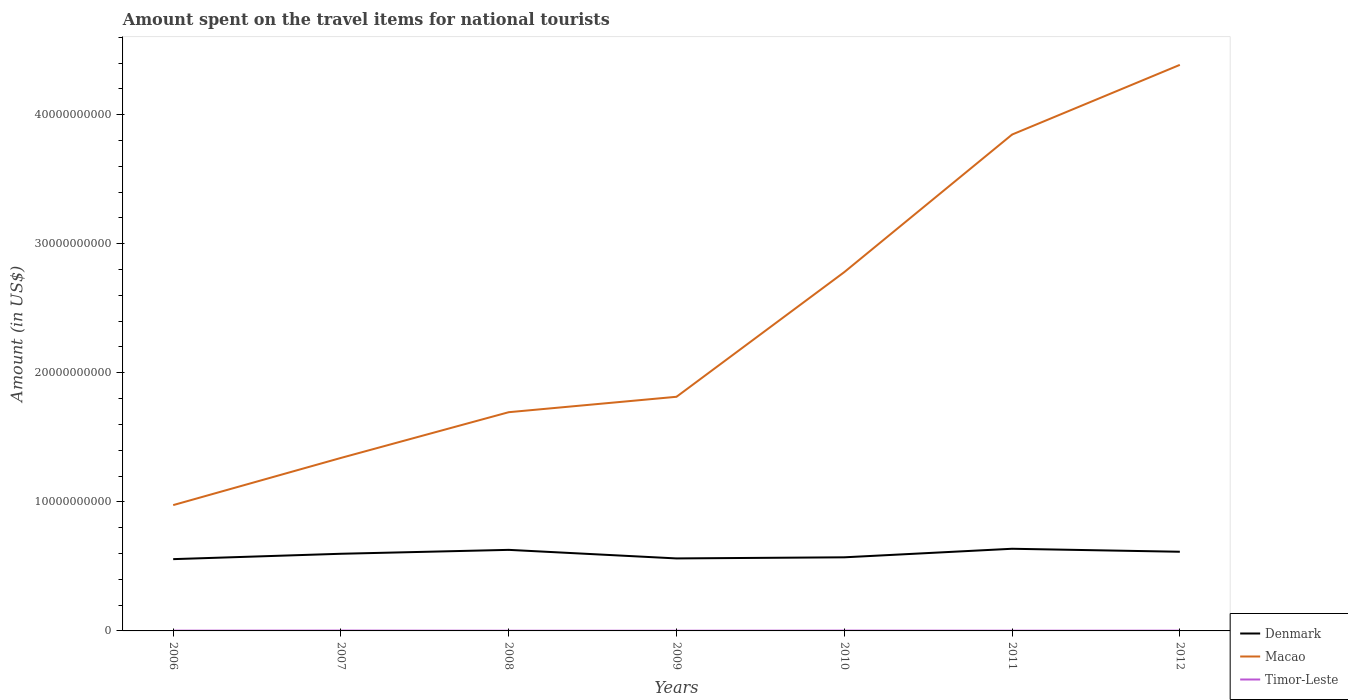How many different coloured lines are there?
Keep it short and to the point. 3. Does the line corresponding to Macao intersect with the line corresponding to Timor-Leste?
Make the answer very short. No. Is the number of lines equal to the number of legend labels?
Give a very brief answer. Yes. Across all years, what is the maximum amount spent on the travel items for national tourists in Timor-Leste?
Keep it short and to the point. 1.40e+07. In which year was the amount spent on the travel items for national tourists in Macao maximum?
Give a very brief answer. 2006. What is the total amount spent on the travel items for national tourists in Denmark in the graph?
Your response must be concise. -6.62e+08. What is the difference between the highest and the second highest amount spent on the travel items for national tourists in Denmark?
Ensure brevity in your answer.  8.04e+08. What is the difference between the highest and the lowest amount spent on the travel items for national tourists in Timor-Leste?
Ensure brevity in your answer.  4. Is the amount spent on the travel items for national tourists in Denmark strictly greater than the amount spent on the travel items for national tourists in Timor-Leste over the years?
Your answer should be compact. No. How many years are there in the graph?
Offer a terse response. 7. What is the difference between two consecutive major ticks on the Y-axis?
Keep it short and to the point. 1.00e+1. Does the graph contain any zero values?
Offer a very short reply. No. Does the graph contain grids?
Make the answer very short. No. Where does the legend appear in the graph?
Your answer should be compact. Bottom right. How many legend labels are there?
Give a very brief answer. 3. How are the legend labels stacked?
Offer a very short reply. Vertical. What is the title of the graph?
Offer a very short reply. Amount spent on the travel items for national tourists. What is the Amount (in US$) in Denmark in 2006?
Offer a very short reply. 5.56e+09. What is the Amount (in US$) in Macao in 2006?
Give a very brief answer. 9.75e+09. What is the Amount (in US$) of Timor-Leste in 2006?
Your answer should be compact. 2.00e+07. What is the Amount (in US$) in Denmark in 2007?
Make the answer very short. 5.98e+09. What is the Amount (in US$) of Macao in 2007?
Your answer should be very brief. 1.34e+1. What is the Amount (in US$) in Timor-Leste in 2007?
Make the answer very short. 2.60e+07. What is the Amount (in US$) in Denmark in 2008?
Your answer should be compact. 6.28e+09. What is the Amount (in US$) in Macao in 2008?
Offer a terse response. 1.69e+1. What is the Amount (in US$) of Timor-Leste in 2008?
Give a very brief answer. 1.40e+07. What is the Amount (in US$) of Denmark in 2009?
Your answer should be very brief. 5.62e+09. What is the Amount (in US$) of Macao in 2009?
Make the answer very short. 1.81e+1. What is the Amount (in US$) of Timor-Leste in 2009?
Make the answer very short. 1.60e+07. What is the Amount (in US$) of Denmark in 2010?
Keep it short and to the point. 5.70e+09. What is the Amount (in US$) in Macao in 2010?
Keep it short and to the point. 2.78e+1. What is the Amount (in US$) in Timor-Leste in 2010?
Offer a very short reply. 2.40e+07. What is the Amount (in US$) of Denmark in 2011?
Your response must be concise. 6.37e+09. What is the Amount (in US$) of Macao in 2011?
Ensure brevity in your answer.  3.85e+1. What is the Amount (in US$) in Timor-Leste in 2011?
Your response must be concise. 1.80e+07. What is the Amount (in US$) in Denmark in 2012?
Provide a short and direct response. 6.14e+09. What is the Amount (in US$) of Macao in 2012?
Your answer should be very brief. 4.39e+1. What is the Amount (in US$) of Timor-Leste in 2012?
Provide a succinct answer. 2.10e+07. Across all years, what is the maximum Amount (in US$) of Denmark?
Your response must be concise. 6.37e+09. Across all years, what is the maximum Amount (in US$) of Macao?
Give a very brief answer. 4.39e+1. Across all years, what is the maximum Amount (in US$) of Timor-Leste?
Your response must be concise. 2.60e+07. Across all years, what is the minimum Amount (in US$) of Denmark?
Offer a terse response. 5.56e+09. Across all years, what is the minimum Amount (in US$) of Macao?
Your answer should be very brief. 9.75e+09. Across all years, what is the minimum Amount (in US$) in Timor-Leste?
Offer a very short reply. 1.40e+07. What is the total Amount (in US$) in Denmark in the graph?
Make the answer very short. 4.16e+1. What is the total Amount (in US$) of Macao in the graph?
Make the answer very short. 1.68e+11. What is the total Amount (in US$) of Timor-Leste in the graph?
Provide a succinct answer. 1.39e+08. What is the difference between the Amount (in US$) in Denmark in 2006 and that in 2007?
Your response must be concise. -4.16e+08. What is the difference between the Amount (in US$) in Macao in 2006 and that in 2007?
Offer a terse response. -3.66e+09. What is the difference between the Amount (in US$) of Timor-Leste in 2006 and that in 2007?
Ensure brevity in your answer.  -6.00e+06. What is the difference between the Amount (in US$) of Denmark in 2006 and that in 2008?
Give a very brief answer. -7.19e+08. What is the difference between the Amount (in US$) of Macao in 2006 and that in 2008?
Your response must be concise. -7.20e+09. What is the difference between the Amount (in US$) in Timor-Leste in 2006 and that in 2008?
Provide a succinct answer. 6.00e+06. What is the difference between the Amount (in US$) in Denmark in 2006 and that in 2009?
Keep it short and to the point. -5.50e+07. What is the difference between the Amount (in US$) in Macao in 2006 and that in 2009?
Your answer should be very brief. -8.39e+09. What is the difference between the Amount (in US$) of Denmark in 2006 and that in 2010?
Your response must be concise. -1.42e+08. What is the difference between the Amount (in US$) of Macao in 2006 and that in 2010?
Make the answer very short. -1.81e+1. What is the difference between the Amount (in US$) in Timor-Leste in 2006 and that in 2010?
Give a very brief answer. -4.00e+06. What is the difference between the Amount (in US$) in Denmark in 2006 and that in 2011?
Your answer should be very brief. -8.04e+08. What is the difference between the Amount (in US$) of Macao in 2006 and that in 2011?
Your response must be concise. -2.87e+1. What is the difference between the Amount (in US$) in Timor-Leste in 2006 and that in 2011?
Keep it short and to the point. 2.00e+06. What is the difference between the Amount (in US$) in Denmark in 2006 and that in 2012?
Your response must be concise. -5.73e+08. What is the difference between the Amount (in US$) in Macao in 2006 and that in 2012?
Provide a succinct answer. -3.41e+1. What is the difference between the Amount (in US$) of Timor-Leste in 2006 and that in 2012?
Provide a short and direct response. -1.00e+06. What is the difference between the Amount (in US$) of Denmark in 2007 and that in 2008?
Make the answer very short. -3.03e+08. What is the difference between the Amount (in US$) in Macao in 2007 and that in 2008?
Keep it short and to the point. -3.54e+09. What is the difference between the Amount (in US$) in Denmark in 2007 and that in 2009?
Your answer should be very brief. 3.61e+08. What is the difference between the Amount (in US$) of Macao in 2007 and that in 2009?
Ensure brevity in your answer.  -4.74e+09. What is the difference between the Amount (in US$) of Denmark in 2007 and that in 2010?
Your answer should be very brief. 2.74e+08. What is the difference between the Amount (in US$) of Macao in 2007 and that in 2010?
Provide a succinct answer. -1.44e+1. What is the difference between the Amount (in US$) in Timor-Leste in 2007 and that in 2010?
Keep it short and to the point. 2.00e+06. What is the difference between the Amount (in US$) in Denmark in 2007 and that in 2011?
Offer a terse response. -3.88e+08. What is the difference between the Amount (in US$) of Macao in 2007 and that in 2011?
Provide a succinct answer. -2.51e+1. What is the difference between the Amount (in US$) of Denmark in 2007 and that in 2012?
Offer a terse response. -1.57e+08. What is the difference between the Amount (in US$) of Macao in 2007 and that in 2012?
Keep it short and to the point. -3.05e+1. What is the difference between the Amount (in US$) in Timor-Leste in 2007 and that in 2012?
Offer a very short reply. 5.00e+06. What is the difference between the Amount (in US$) in Denmark in 2008 and that in 2009?
Your answer should be very brief. 6.64e+08. What is the difference between the Amount (in US$) of Macao in 2008 and that in 2009?
Your response must be concise. -1.19e+09. What is the difference between the Amount (in US$) in Denmark in 2008 and that in 2010?
Provide a succinct answer. 5.77e+08. What is the difference between the Amount (in US$) of Macao in 2008 and that in 2010?
Make the answer very short. -1.09e+1. What is the difference between the Amount (in US$) in Timor-Leste in 2008 and that in 2010?
Ensure brevity in your answer.  -1.00e+07. What is the difference between the Amount (in US$) of Denmark in 2008 and that in 2011?
Keep it short and to the point. -8.50e+07. What is the difference between the Amount (in US$) of Macao in 2008 and that in 2011?
Give a very brief answer. -2.15e+1. What is the difference between the Amount (in US$) in Timor-Leste in 2008 and that in 2011?
Your answer should be very brief. -4.00e+06. What is the difference between the Amount (in US$) in Denmark in 2008 and that in 2012?
Your response must be concise. 1.46e+08. What is the difference between the Amount (in US$) in Macao in 2008 and that in 2012?
Keep it short and to the point. -2.69e+1. What is the difference between the Amount (in US$) of Timor-Leste in 2008 and that in 2012?
Provide a succinct answer. -7.00e+06. What is the difference between the Amount (in US$) in Denmark in 2009 and that in 2010?
Ensure brevity in your answer.  -8.70e+07. What is the difference between the Amount (in US$) of Macao in 2009 and that in 2010?
Offer a very short reply. -9.66e+09. What is the difference between the Amount (in US$) of Timor-Leste in 2009 and that in 2010?
Provide a short and direct response. -8.00e+06. What is the difference between the Amount (in US$) in Denmark in 2009 and that in 2011?
Keep it short and to the point. -7.49e+08. What is the difference between the Amount (in US$) in Macao in 2009 and that in 2011?
Offer a very short reply. -2.03e+1. What is the difference between the Amount (in US$) of Timor-Leste in 2009 and that in 2011?
Your response must be concise. -2.00e+06. What is the difference between the Amount (in US$) of Denmark in 2009 and that in 2012?
Keep it short and to the point. -5.18e+08. What is the difference between the Amount (in US$) in Macao in 2009 and that in 2012?
Make the answer very short. -2.57e+1. What is the difference between the Amount (in US$) of Timor-Leste in 2009 and that in 2012?
Your answer should be very brief. -5.00e+06. What is the difference between the Amount (in US$) in Denmark in 2010 and that in 2011?
Your response must be concise. -6.62e+08. What is the difference between the Amount (in US$) in Macao in 2010 and that in 2011?
Offer a terse response. -1.07e+1. What is the difference between the Amount (in US$) of Timor-Leste in 2010 and that in 2011?
Provide a short and direct response. 6.00e+06. What is the difference between the Amount (in US$) in Denmark in 2010 and that in 2012?
Offer a very short reply. -4.31e+08. What is the difference between the Amount (in US$) of Macao in 2010 and that in 2012?
Provide a succinct answer. -1.61e+1. What is the difference between the Amount (in US$) in Denmark in 2011 and that in 2012?
Offer a terse response. 2.31e+08. What is the difference between the Amount (in US$) of Macao in 2011 and that in 2012?
Provide a succinct answer. -5.40e+09. What is the difference between the Amount (in US$) of Timor-Leste in 2011 and that in 2012?
Your answer should be compact. -3.00e+06. What is the difference between the Amount (in US$) of Denmark in 2006 and the Amount (in US$) of Macao in 2007?
Provide a succinct answer. -7.84e+09. What is the difference between the Amount (in US$) of Denmark in 2006 and the Amount (in US$) of Timor-Leste in 2007?
Provide a succinct answer. 5.54e+09. What is the difference between the Amount (in US$) of Macao in 2006 and the Amount (in US$) of Timor-Leste in 2007?
Your response must be concise. 9.72e+09. What is the difference between the Amount (in US$) in Denmark in 2006 and the Amount (in US$) in Macao in 2008?
Make the answer very short. -1.14e+1. What is the difference between the Amount (in US$) in Denmark in 2006 and the Amount (in US$) in Timor-Leste in 2008?
Your answer should be compact. 5.55e+09. What is the difference between the Amount (in US$) of Macao in 2006 and the Amount (in US$) of Timor-Leste in 2008?
Your answer should be very brief. 9.74e+09. What is the difference between the Amount (in US$) in Denmark in 2006 and the Amount (in US$) in Macao in 2009?
Your response must be concise. -1.26e+1. What is the difference between the Amount (in US$) in Denmark in 2006 and the Amount (in US$) in Timor-Leste in 2009?
Keep it short and to the point. 5.55e+09. What is the difference between the Amount (in US$) in Macao in 2006 and the Amount (in US$) in Timor-Leste in 2009?
Offer a terse response. 9.73e+09. What is the difference between the Amount (in US$) of Denmark in 2006 and the Amount (in US$) of Macao in 2010?
Keep it short and to the point. -2.22e+1. What is the difference between the Amount (in US$) of Denmark in 2006 and the Amount (in US$) of Timor-Leste in 2010?
Make the answer very short. 5.54e+09. What is the difference between the Amount (in US$) of Macao in 2006 and the Amount (in US$) of Timor-Leste in 2010?
Make the answer very short. 9.72e+09. What is the difference between the Amount (in US$) in Denmark in 2006 and the Amount (in US$) in Macao in 2011?
Your answer should be very brief. -3.29e+1. What is the difference between the Amount (in US$) of Denmark in 2006 and the Amount (in US$) of Timor-Leste in 2011?
Give a very brief answer. 5.54e+09. What is the difference between the Amount (in US$) of Macao in 2006 and the Amount (in US$) of Timor-Leste in 2011?
Your answer should be very brief. 9.73e+09. What is the difference between the Amount (in US$) in Denmark in 2006 and the Amount (in US$) in Macao in 2012?
Provide a succinct answer. -3.83e+1. What is the difference between the Amount (in US$) of Denmark in 2006 and the Amount (in US$) of Timor-Leste in 2012?
Provide a succinct answer. 5.54e+09. What is the difference between the Amount (in US$) in Macao in 2006 and the Amount (in US$) in Timor-Leste in 2012?
Ensure brevity in your answer.  9.73e+09. What is the difference between the Amount (in US$) of Denmark in 2007 and the Amount (in US$) of Macao in 2008?
Your answer should be compact. -1.10e+1. What is the difference between the Amount (in US$) in Denmark in 2007 and the Amount (in US$) in Timor-Leste in 2008?
Your answer should be very brief. 5.96e+09. What is the difference between the Amount (in US$) of Macao in 2007 and the Amount (in US$) of Timor-Leste in 2008?
Your answer should be very brief. 1.34e+1. What is the difference between the Amount (in US$) in Denmark in 2007 and the Amount (in US$) in Macao in 2009?
Provide a succinct answer. -1.22e+1. What is the difference between the Amount (in US$) in Denmark in 2007 and the Amount (in US$) in Timor-Leste in 2009?
Offer a very short reply. 5.96e+09. What is the difference between the Amount (in US$) in Macao in 2007 and the Amount (in US$) in Timor-Leste in 2009?
Give a very brief answer. 1.34e+1. What is the difference between the Amount (in US$) of Denmark in 2007 and the Amount (in US$) of Macao in 2010?
Make the answer very short. -2.18e+1. What is the difference between the Amount (in US$) of Denmark in 2007 and the Amount (in US$) of Timor-Leste in 2010?
Your answer should be very brief. 5.95e+09. What is the difference between the Amount (in US$) of Macao in 2007 and the Amount (in US$) of Timor-Leste in 2010?
Your response must be concise. 1.34e+1. What is the difference between the Amount (in US$) of Denmark in 2007 and the Amount (in US$) of Macao in 2011?
Offer a very short reply. -3.25e+1. What is the difference between the Amount (in US$) in Denmark in 2007 and the Amount (in US$) in Timor-Leste in 2011?
Make the answer very short. 5.96e+09. What is the difference between the Amount (in US$) of Macao in 2007 and the Amount (in US$) of Timor-Leste in 2011?
Ensure brevity in your answer.  1.34e+1. What is the difference between the Amount (in US$) of Denmark in 2007 and the Amount (in US$) of Macao in 2012?
Ensure brevity in your answer.  -3.79e+1. What is the difference between the Amount (in US$) of Denmark in 2007 and the Amount (in US$) of Timor-Leste in 2012?
Provide a succinct answer. 5.96e+09. What is the difference between the Amount (in US$) in Macao in 2007 and the Amount (in US$) in Timor-Leste in 2012?
Your response must be concise. 1.34e+1. What is the difference between the Amount (in US$) in Denmark in 2008 and the Amount (in US$) in Macao in 2009?
Offer a very short reply. -1.19e+1. What is the difference between the Amount (in US$) in Denmark in 2008 and the Amount (in US$) in Timor-Leste in 2009?
Make the answer very short. 6.26e+09. What is the difference between the Amount (in US$) in Macao in 2008 and the Amount (in US$) in Timor-Leste in 2009?
Offer a very short reply. 1.69e+1. What is the difference between the Amount (in US$) in Denmark in 2008 and the Amount (in US$) in Macao in 2010?
Offer a very short reply. -2.15e+1. What is the difference between the Amount (in US$) in Denmark in 2008 and the Amount (in US$) in Timor-Leste in 2010?
Ensure brevity in your answer.  6.26e+09. What is the difference between the Amount (in US$) in Macao in 2008 and the Amount (in US$) in Timor-Leste in 2010?
Give a very brief answer. 1.69e+1. What is the difference between the Amount (in US$) in Denmark in 2008 and the Amount (in US$) in Macao in 2011?
Provide a succinct answer. -3.22e+1. What is the difference between the Amount (in US$) in Denmark in 2008 and the Amount (in US$) in Timor-Leste in 2011?
Offer a very short reply. 6.26e+09. What is the difference between the Amount (in US$) of Macao in 2008 and the Amount (in US$) of Timor-Leste in 2011?
Your answer should be very brief. 1.69e+1. What is the difference between the Amount (in US$) in Denmark in 2008 and the Amount (in US$) in Macao in 2012?
Make the answer very short. -3.76e+1. What is the difference between the Amount (in US$) in Denmark in 2008 and the Amount (in US$) in Timor-Leste in 2012?
Offer a terse response. 6.26e+09. What is the difference between the Amount (in US$) in Macao in 2008 and the Amount (in US$) in Timor-Leste in 2012?
Keep it short and to the point. 1.69e+1. What is the difference between the Amount (in US$) in Denmark in 2009 and the Amount (in US$) in Macao in 2010?
Your response must be concise. -2.22e+1. What is the difference between the Amount (in US$) of Denmark in 2009 and the Amount (in US$) of Timor-Leste in 2010?
Your answer should be compact. 5.59e+09. What is the difference between the Amount (in US$) in Macao in 2009 and the Amount (in US$) in Timor-Leste in 2010?
Give a very brief answer. 1.81e+1. What is the difference between the Amount (in US$) in Denmark in 2009 and the Amount (in US$) in Macao in 2011?
Make the answer very short. -3.28e+1. What is the difference between the Amount (in US$) in Denmark in 2009 and the Amount (in US$) in Timor-Leste in 2011?
Provide a short and direct response. 5.60e+09. What is the difference between the Amount (in US$) in Macao in 2009 and the Amount (in US$) in Timor-Leste in 2011?
Keep it short and to the point. 1.81e+1. What is the difference between the Amount (in US$) in Denmark in 2009 and the Amount (in US$) in Macao in 2012?
Provide a short and direct response. -3.82e+1. What is the difference between the Amount (in US$) of Denmark in 2009 and the Amount (in US$) of Timor-Leste in 2012?
Make the answer very short. 5.60e+09. What is the difference between the Amount (in US$) in Macao in 2009 and the Amount (in US$) in Timor-Leste in 2012?
Offer a terse response. 1.81e+1. What is the difference between the Amount (in US$) of Denmark in 2010 and the Amount (in US$) of Macao in 2011?
Ensure brevity in your answer.  -3.28e+1. What is the difference between the Amount (in US$) in Denmark in 2010 and the Amount (in US$) in Timor-Leste in 2011?
Your response must be concise. 5.69e+09. What is the difference between the Amount (in US$) of Macao in 2010 and the Amount (in US$) of Timor-Leste in 2011?
Offer a very short reply. 2.78e+1. What is the difference between the Amount (in US$) in Denmark in 2010 and the Amount (in US$) in Macao in 2012?
Your answer should be compact. -3.82e+1. What is the difference between the Amount (in US$) of Denmark in 2010 and the Amount (in US$) of Timor-Leste in 2012?
Keep it short and to the point. 5.68e+09. What is the difference between the Amount (in US$) of Macao in 2010 and the Amount (in US$) of Timor-Leste in 2012?
Offer a terse response. 2.78e+1. What is the difference between the Amount (in US$) in Denmark in 2011 and the Amount (in US$) in Macao in 2012?
Your answer should be compact. -3.75e+1. What is the difference between the Amount (in US$) in Denmark in 2011 and the Amount (in US$) in Timor-Leste in 2012?
Provide a succinct answer. 6.34e+09. What is the difference between the Amount (in US$) of Macao in 2011 and the Amount (in US$) of Timor-Leste in 2012?
Your answer should be very brief. 3.84e+1. What is the average Amount (in US$) of Denmark per year?
Provide a succinct answer. 5.95e+09. What is the average Amount (in US$) in Macao per year?
Make the answer very short. 2.41e+1. What is the average Amount (in US$) of Timor-Leste per year?
Make the answer very short. 1.99e+07. In the year 2006, what is the difference between the Amount (in US$) in Denmark and Amount (in US$) in Macao?
Your answer should be compact. -4.19e+09. In the year 2006, what is the difference between the Amount (in US$) of Denmark and Amount (in US$) of Timor-Leste?
Offer a very short reply. 5.54e+09. In the year 2006, what is the difference between the Amount (in US$) of Macao and Amount (in US$) of Timor-Leste?
Your answer should be compact. 9.73e+09. In the year 2007, what is the difference between the Amount (in US$) of Denmark and Amount (in US$) of Macao?
Offer a very short reply. -7.43e+09. In the year 2007, what is the difference between the Amount (in US$) of Denmark and Amount (in US$) of Timor-Leste?
Your answer should be compact. 5.95e+09. In the year 2007, what is the difference between the Amount (in US$) in Macao and Amount (in US$) in Timor-Leste?
Keep it short and to the point. 1.34e+1. In the year 2008, what is the difference between the Amount (in US$) in Denmark and Amount (in US$) in Macao?
Ensure brevity in your answer.  -1.07e+1. In the year 2008, what is the difference between the Amount (in US$) of Denmark and Amount (in US$) of Timor-Leste?
Ensure brevity in your answer.  6.27e+09. In the year 2008, what is the difference between the Amount (in US$) in Macao and Amount (in US$) in Timor-Leste?
Your answer should be compact. 1.69e+1. In the year 2009, what is the difference between the Amount (in US$) of Denmark and Amount (in US$) of Macao?
Keep it short and to the point. -1.25e+1. In the year 2009, what is the difference between the Amount (in US$) of Denmark and Amount (in US$) of Timor-Leste?
Keep it short and to the point. 5.60e+09. In the year 2009, what is the difference between the Amount (in US$) of Macao and Amount (in US$) of Timor-Leste?
Your answer should be very brief. 1.81e+1. In the year 2010, what is the difference between the Amount (in US$) in Denmark and Amount (in US$) in Macao?
Your answer should be compact. -2.21e+1. In the year 2010, what is the difference between the Amount (in US$) in Denmark and Amount (in US$) in Timor-Leste?
Give a very brief answer. 5.68e+09. In the year 2010, what is the difference between the Amount (in US$) of Macao and Amount (in US$) of Timor-Leste?
Ensure brevity in your answer.  2.78e+1. In the year 2011, what is the difference between the Amount (in US$) in Denmark and Amount (in US$) in Macao?
Keep it short and to the point. -3.21e+1. In the year 2011, what is the difference between the Amount (in US$) in Denmark and Amount (in US$) in Timor-Leste?
Provide a succinct answer. 6.35e+09. In the year 2011, what is the difference between the Amount (in US$) of Macao and Amount (in US$) of Timor-Leste?
Ensure brevity in your answer.  3.84e+1. In the year 2012, what is the difference between the Amount (in US$) in Denmark and Amount (in US$) in Macao?
Your answer should be compact. -3.77e+1. In the year 2012, what is the difference between the Amount (in US$) of Denmark and Amount (in US$) of Timor-Leste?
Offer a very short reply. 6.11e+09. In the year 2012, what is the difference between the Amount (in US$) of Macao and Amount (in US$) of Timor-Leste?
Give a very brief answer. 4.38e+1. What is the ratio of the Amount (in US$) of Denmark in 2006 to that in 2007?
Provide a succinct answer. 0.93. What is the ratio of the Amount (in US$) of Macao in 2006 to that in 2007?
Make the answer very short. 0.73. What is the ratio of the Amount (in US$) of Timor-Leste in 2006 to that in 2007?
Your response must be concise. 0.77. What is the ratio of the Amount (in US$) in Denmark in 2006 to that in 2008?
Your answer should be compact. 0.89. What is the ratio of the Amount (in US$) of Macao in 2006 to that in 2008?
Your answer should be very brief. 0.58. What is the ratio of the Amount (in US$) of Timor-Leste in 2006 to that in 2008?
Offer a very short reply. 1.43. What is the ratio of the Amount (in US$) of Denmark in 2006 to that in 2009?
Provide a succinct answer. 0.99. What is the ratio of the Amount (in US$) in Macao in 2006 to that in 2009?
Offer a very short reply. 0.54. What is the ratio of the Amount (in US$) of Denmark in 2006 to that in 2010?
Make the answer very short. 0.98. What is the ratio of the Amount (in US$) of Macao in 2006 to that in 2010?
Keep it short and to the point. 0.35. What is the ratio of the Amount (in US$) in Timor-Leste in 2006 to that in 2010?
Provide a succinct answer. 0.83. What is the ratio of the Amount (in US$) of Denmark in 2006 to that in 2011?
Your response must be concise. 0.87. What is the ratio of the Amount (in US$) in Macao in 2006 to that in 2011?
Provide a short and direct response. 0.25. What is the ratio of the Amount (in US$) in Timor-Leste in 2006 to that in 2011?
Keep it short and to the point. 1.11. What is the ratio of the Amount (in US$) in Denmark in 2006 to that in 2012?
Your answer should be compact. 0.91. What is the ratio of the Amount (in US$) in Macao in 2006 to that in 2012?
Keep it short and to the point. 0.22. What is the ratio of the Amount (in US$) in Timor-Leste in 2006 to that in 2012?
Provide a succinct answer. 0.95. What is the ratio of the Amount (in US$) in Denmark in 2007 to that in 2008?
Make the answer very short. 0.95. What is the ratio of the Amount (in US$) in Macao in 2007 to that in 2008?
Your answer should be very brief. 0.79. What is the ratio of the Amount (in US$) of Timor-Leste in 2007 to that in 2008?
Your response must be concise. 1.86. What is the ratio of the Amount (in US$) in Denmark in 2007 to that in 2009?
Provide a succinct answer. 1.06. What is the ratio of the Amount (in US$) in Macao in 2007 to that in 2009?
Your answer should be very brief. 0.74. What is the ratio of the Amount (in US$) of Timor-Leste in 2007 to that in 2009?
Give a very brief answer. 1.62. What is the ratio of the Amount (in US$) in Denmark in 2007 to that in 2010?
Provide a short and direct response. 1.05. What is the ratio of the Amount (in US$) in Macao in 2007 to that in 2010?
Provide a succinct answer. 0.48. What is the ratio of the Amount (in US$) in Timor-Leste in 2007 to that in 2010?
Give a very brief answer. 1.08. What is the ratio of the Amount (in US$) in Denmark in 2007 to that in 2011?
Your response must be concise. 0.94. What is the ratio of the Amount (in US$) of Macao in 2007 to that in 2011?
Offer a very short reply. 0.35. What is the ratio of the Amount (in US$) of Timor-Leste in 2007 to that in 2011?
Your response must be concise. 1.44. What is the ratio of the Amount (in US$) in Denmark in 2007 to that in 2012?
Keep it short and to the point. 0.97. What is the ratio of the Amount (in US$) of Macao in 2007 to that in 2012?
Offer a terse response. 0.31. What is the ratio of the Amount (in US$) in Timor-Leste in 2007 to that in 2012?
Offer a very short reply. 1.24. What is the ratio of the Amount (in US$) of Denmark in 2008 to that in 2009?
Make the answer very short. 1.12. What is the ratio of the Amount (in US$) in Macao in 2008 to that in 2009?
Your answer should be very brief. 0.93. What is the ratio of the Amount (in US$) in Denmark in 2008 to that in 2010?
Your answer should be very brief. 1.1. What is the ratio of the Amount (in US$) of Macao in 2008 to that in 2010?
Provide a succinct answer. 0.61. What is the ratio of the Amount (in US$) of Timor-Leste in 2008 to that in 2010?
Provide a succinct answer. 0.58. What is the ratio of the Amount (in US$) in Denmark in 2008 to that in 2011?
Your response must be concise. 0.99. What is the ratio of the Amount (in US$) in Macao in 2008 to that in 2011?
Your answer should be very brief. 0.44. What is the ratio of the Amount (in US$) in Timor-Leste in 2008 to that in 2011?
Your answer should be very brief. 0.78. What is the ratio of the Amount (in US$) of Denmark in 2008 to that in 2012?
Your answer should be very brief. 1.02. What is the ratio of the Amount (in US$) of Macao in 2008 to that in 2012?
Offer a very short reply. 0.39. What is the ratio of the Amount (in US$) in Denmark in 2009 to that in 2010?
Your response must be concise. 0.98. What is the ratio of the Amount (in US$) in Macao in 2009 to that in 2010?
Your answer should be very brief. 0.65. What is the ratio of the Amount (in US$) of Denmark in 2009 to that in 2011?
Offer a terse response. 0.88. What is the ratio of the Amount (in US$) of Macao in 2009 to that in 2011?
Offer a terse response. 0.47. What is the ratio of the Amount (in US$) of Denmark in 2009 to that in 2012?
Ensure brevity in your answer.  0.92. What is the ratio of the Amount (in US$) in Macao in 2009 to that in 2012?
Your response must be concise. 0.41. What is the ratio of the Amount (in US$) of Timor-Leste in 2009 to that in 2012?
Ensure brevity in your answer.  0.76. What is the ratio of the Amount (in US$) in Denmark in 2010 to that in 2011?
Provide a succinct answer. 0.9. What is the ratio of the Amount (in US$) of Macao in 2010 to that in 2011?
Give a very brief answer. 0.72. What is the ratio of the Amount (in US$) in Denmark in 2010 to that in 2012?
Your answer should be very brief. 0.93. What is the ratio of the Amount (in US$) of Macao in 2010 to that in 2012?
Ensure brevity in your answer.  0.63. What is the ratio of the Amount (in US$) of Denmark in 2011 to that in 2012?
Offer a terse response. 1.04. What is the ratio of the Amount (in US$) in Macao in 2011 to that in 2012?
Your response must be concise. 0.88. What is the ratio of the Amount (in US$) of Timor-Leste in 2011 to that in 2012?
Ensure brevity in your answer.  0.86. What is the difference between the highest and the second highest Amount (in US$) of Denmark?
Ensure brevity in your answer.  8.50e+07. What is the difference between the highest and the second highest Amount (in US$) of Macao?
Provide a succinct answer. 5.40e+09. What is the difference between the highest and the second highest Amount (in US$) in Timor-Leste?
Offer a very short reply. 2.00e+06. What is the difference between the highest and the lowest Amount (in US$) in Denmark?
Your response must be concise. 8.04e+08. What is the difference between the highest and the lowest Amount (in US$) in Macao?
Ensure brevity in your answer.  3.41e+1. What is the difference between the highest and the lowest Amount (in US$) of Timor-Leste?
Make the answer very short. 1.20e+07. 